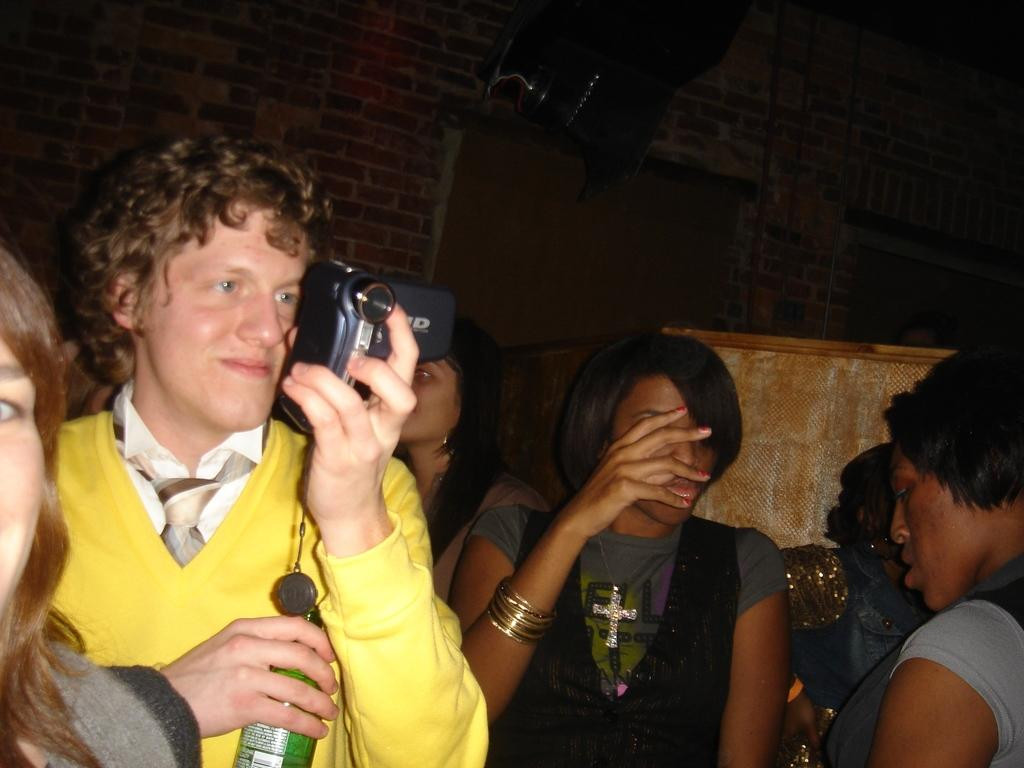Who is the main subject in the image? There is a man in the image. What is the man holding in his hands? The man is holding a bottle and a camera. Are there any other people in the image? Yes, there are people around the man. What type of mist can be seen surrounding the man in the image? There is no mist present in the image. 